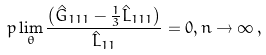<formula> <loc_0><loc_0><loc_500><loc_500>p \lim _ { \theta } \frac { \left ( \hat { G } _ { 1 1 1 } - \frac { 1 } { 3 } \hat { L } _ { 1 1 1 } \right ) } { \hat { L } _ { 1 1 } } = 0 , n \rightarrow \infty \, ,</formula> 